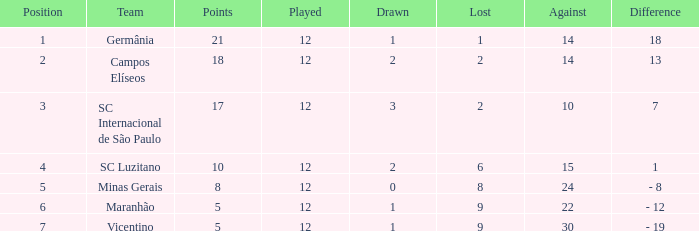What difference has a points greater than 10, and a drawn less than 2? 18.0. Parse the full table. {'header': ['Position', 'Team', 'Points', 'Played', 'Drawn', 'Lost', 'Against', 'Difference'], 'rows': [['1', 'Germânia', '21', '12', '1', '1', '14', '18'], ['2', 'Campos Elíseos', '18', '12', '2', '2', '14', '13'], ['3', 'SC Internacional de São Paulo', '17', '12', '3', '2', '10', '7'], ['4', 'SC Luzitano', '10', '12', '2', '6', '15', '1'], ['5', 'Minas Gerais', '8', '12', '0', '8', '24', '- 8'], ['6', 'Maranhão', '5', '12', '1', '9', '22', '- 12'], ['7', 'Vicentino', '5', '12', '1', '9', '30', '- 19']]} 